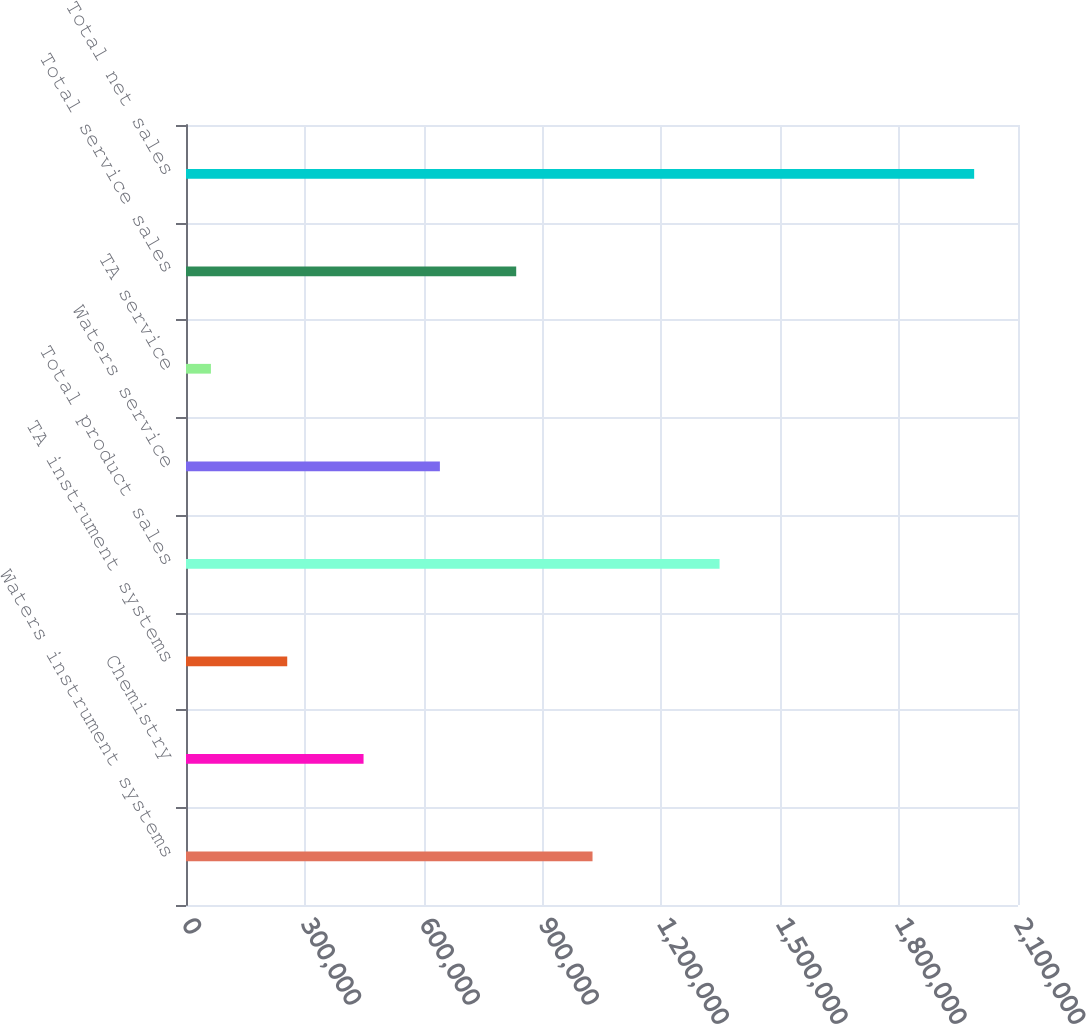Convert chart to OTSL. <chart><loc_0><loc_0><loc_500><loc_500><bar_chart><fcel>Waters instrument systems<fcel>Chemistry<fcel>TA instrument systems<fcel>Total product sales<fcel>Waters service<fcel>TA service<fcel>Total service sales<fcel>Total net sales<nl><fcel>1.0261e+06<fcel>448154<fcel>255505<fcel>1.34673e+06<fcel>640802<fcel>62856<fcel>833451<fcel>1.98934e+06<nl></chart> 